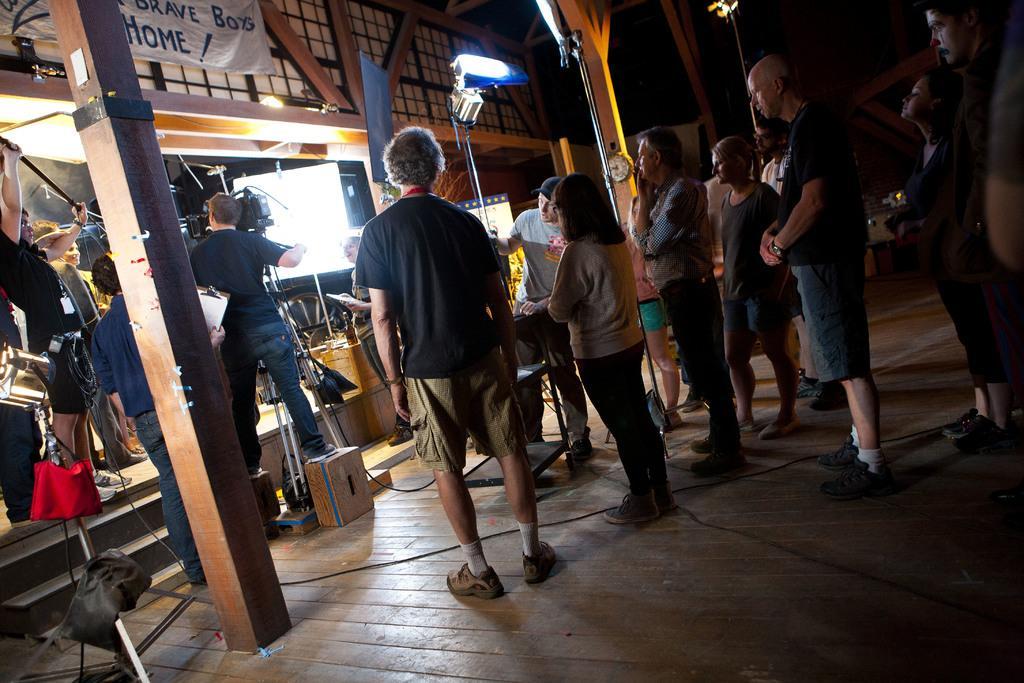Describe this image in one or two sentences. In this image there are few people visible on the floor, there is a camera man holding a camera, there are some lights , banner attached to the top fence, there are some pillars, a clock attached to the pillar, on the left side there is a stand. 